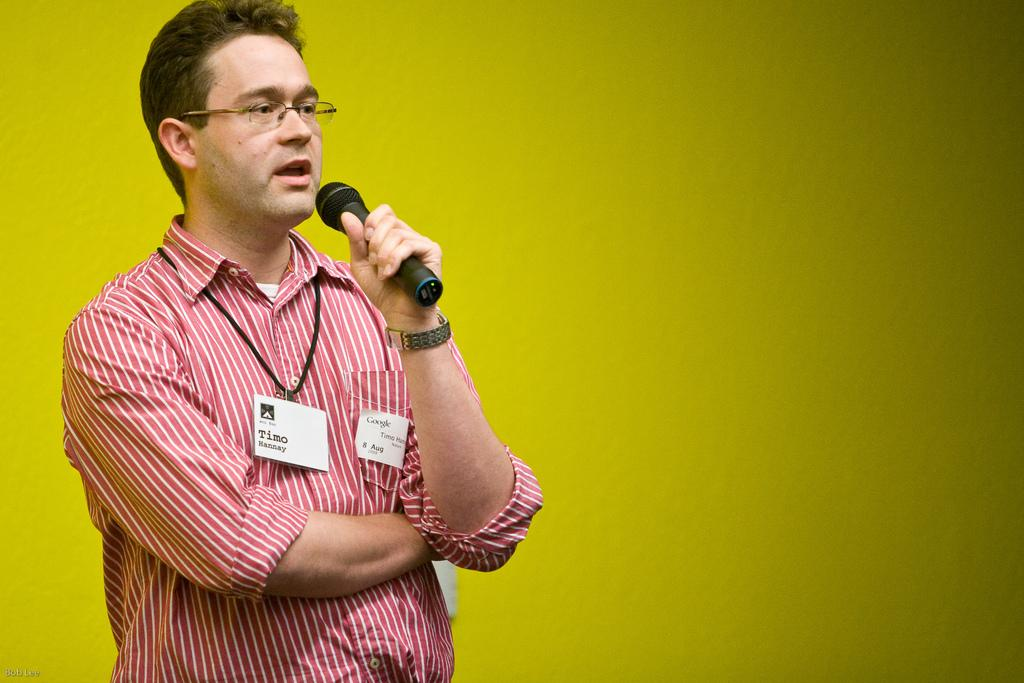What is the main subject of the image? There is a man in the image. What is the man doing in the image? The man is standing in the image. What object is the man holding in the image? The man is holding a mic in the image. What color is the wall visible in the background of the image? There is a yellow wall in the background of the image. What type of suit is the beast wearing in the image? There is no beast or suit present in the image; it features a man holding a mic. How much friction is present between the man's shoes and the floor in the image? The amount of friction between the man's shoes and the floor cannot be determined from the image. 